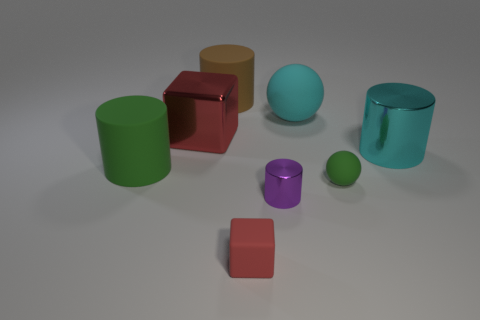What kind of materials do the objects in the image appear to be made of? The objects in the image have a synthetic appearance, possibly resembling plastics or painted metals, indicated by their uniform colors and varying degrees of sheen. 